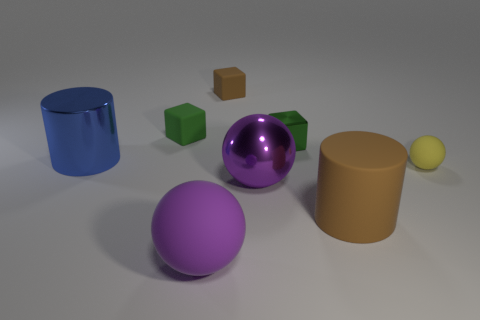Subtract all rubber spheres. How many spheres are left? 1 Subtract all green cylinders. How many green cubes are left? 2 Add 2 big purple rubber spheres. How many objects exist? 10 Subtract all yellow spheres. How many spheres are left? 2 Subtract all cylinders. How many objects are left? 6 Add 4 metal things. How many metal things are left? 7 Add 4 small green rubber cubes. How many small green rubber cubes exist? 5 Subtract 1 brown blocks. How many objects are left? 7 Subtract all blue blocks. Subtract all yellow spheres. How many blocks are left? 3 Subtract all purple matte spheres. Subtract all matte things. How many objects are left? 2 